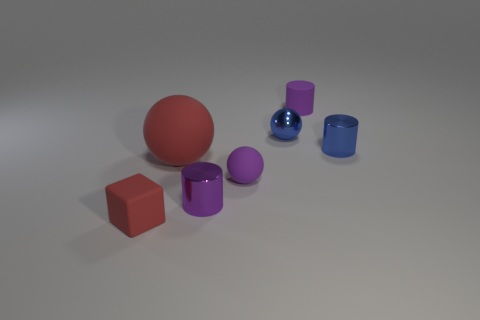How many other objects are there of the same color as the small matte cube?
Provide a short and direct response. 1. How many blue things are either large objects or small rubber things?
Give a very brief answer. 0. Do the large matte object and the tiny purple thing that is behind the blue shiny cylinder have the same shape?
Your answer should be compact. No. The purple metallic object is what shape?
Offer a very short reply. Cylinder. There is a red cube that is the same size as the purple ball; what material is it?
Offer a terse response. Rubber. Is there any other thing that has the same size as the purple shiny cylinder?
Offer a very short reply. Yes. How many things are tiny purple things or purple matte objects in front of the large red sphere?
Make the answer very short. 3. The blue thing that is the same material as the tiny blue cylinder is what size?
Keep it short and to the point. Small. There is a big red thing that is left of the matte object that is behind the red ball; what is its shape?
Your answer should be compact. Sphere. How big is the thing that is both in front of the small metallic sphere and right of the small metallic sphere?
Your answer should be very brief. Small. 